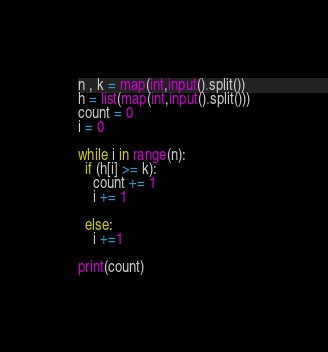Convert code to text. <code><loc_0><loc_0><loc_500><loc_500><_Python_>n , k = map(int,input().split())
h = list(map(int,input().split()))
count = 0
i = 0

while i in range(n):
  if (h[i] >= k):
    count += 1
    i += 1
    
  else:
    i +=1
  
print(count)</code> 